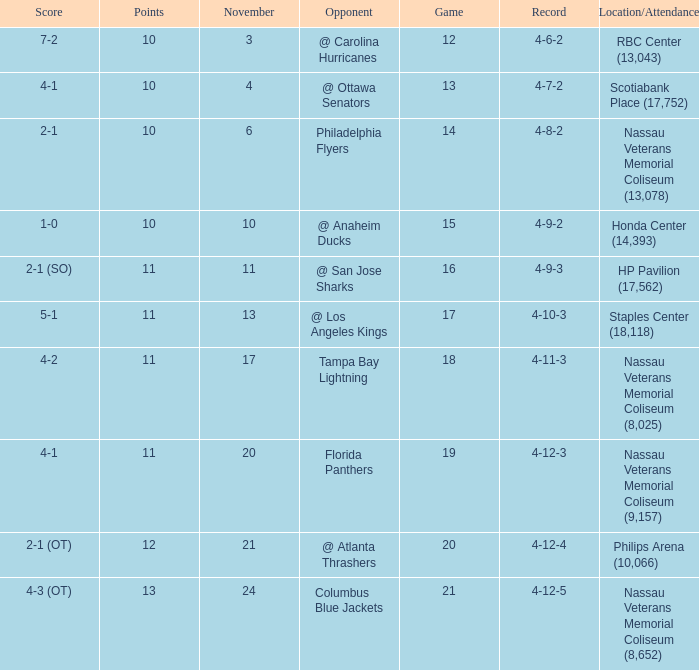Parse the full table. {'header': ['Score', 'Points', 'November', 'Opponent', 'Game', 'Record', 'Location/Attendance'], 'rows': [['7-2', '10', '3', '@ Carolina Hurricanes', '12', '4-6-2', 'RBC Center (13,043)'], ['4-1', '10', '4', '@ Ottawa Senators', '13', '4-7-2', 'Scotiabank Place (17,752)'], ['2-1', '10', '6', 'Philadelphia Flyers', '14', '4-8-2', 'Nassau Veterans Memorial Coliseum (13,078)'], ['1-0', '10', '10', '@ Anaheim Ducks', '15', '4-9-2', 'Honda Center (14,393)'], ['2-1 (SO)', '11', '11', '@ San Jose Sharks', '16', '4-9-3', 'HP Pavilion (17,562)'], ['5-1', '11', '13', '@ Los Angeles Kings', '17', '4-10-3', 'Staples Center (18,118)'], ['4-2', '11', '17', 'Tampa Bay Lightning', '18', '4-11-3', 'Nassau Veterans Memorial Coliseum (8,025)'], ['4-1', '11', '20', 'Florida Panthers', '19', '4-12-3', 'Nassau Veterans Memorial Coliseum (9,157)'], ['2-1 (OT)', '12', '21', '@ Atlanta Thrashers', '20', '4-12-4', 'Philips Arena (10,066)'], ['4-3 (OT)', '13', '24', 'Columbus Blue Jackets', '21', '4-12-5', 'Nassau Veterans Memorial Coliseum (8,652)']]} What is the highest amount of points? 13.0. 